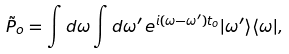<formula> <loc_0><loc_0><loc_500><loc_500>\tilde { P } _ { o } = \int d \omega \int d \omega ^ { \prime } \, e ^ { i ( \omega - \omega ^ { \prime } ) t _ { o } } | \omega ^ { \prime } \rangle \langle \omega | ,</formula> 